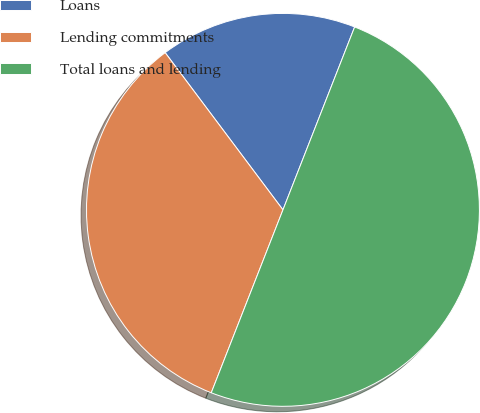Convert chart to OTSL. <chart><loc_0><loc_0><loc_500><loc_500><pie_chart><fcel>Loans<fcel>Lending commitments<fcel>Total loans and lending<nl><fcel>16.18%<fcel>33.82%<fcel>50.0%<nl></chart> 